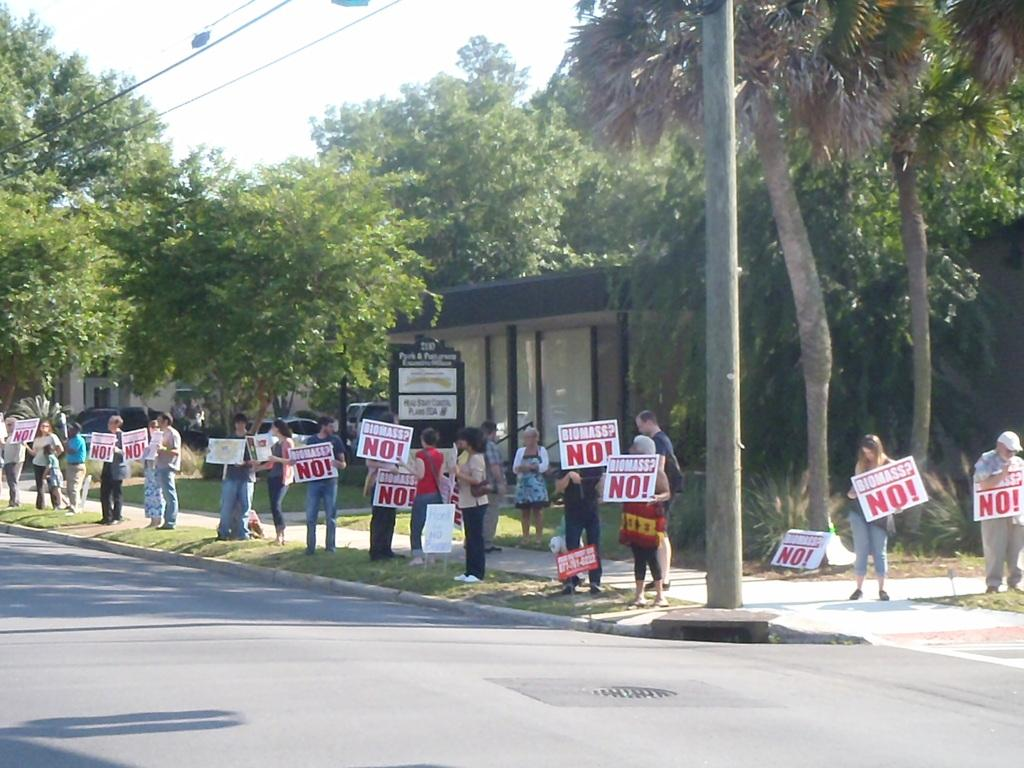<image>
Present a compact description of the photo's key features. Group of people protesting with signs saying biomass No! 